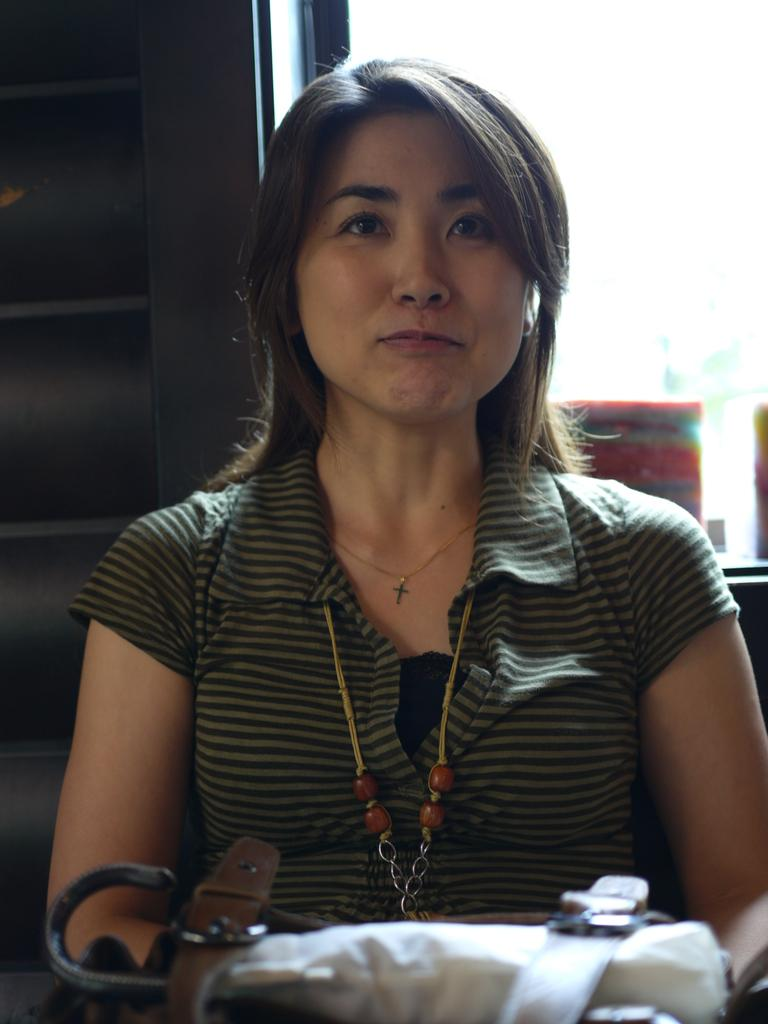Who is the main subject in the image? There is a woman in the image. What is the woman wearing? The woman is wearing a green and black colored dress. What is the woman holding in the image? The woman is holding a bag. How would you describe the background of the image? The background of the image is black and white. What type of attraction is the woman visiting in the image? There is no indication of an attraction in the image; it only shows a woman wearing a green and black colored dress, holding a bag, and standing in front of a black and white background. 